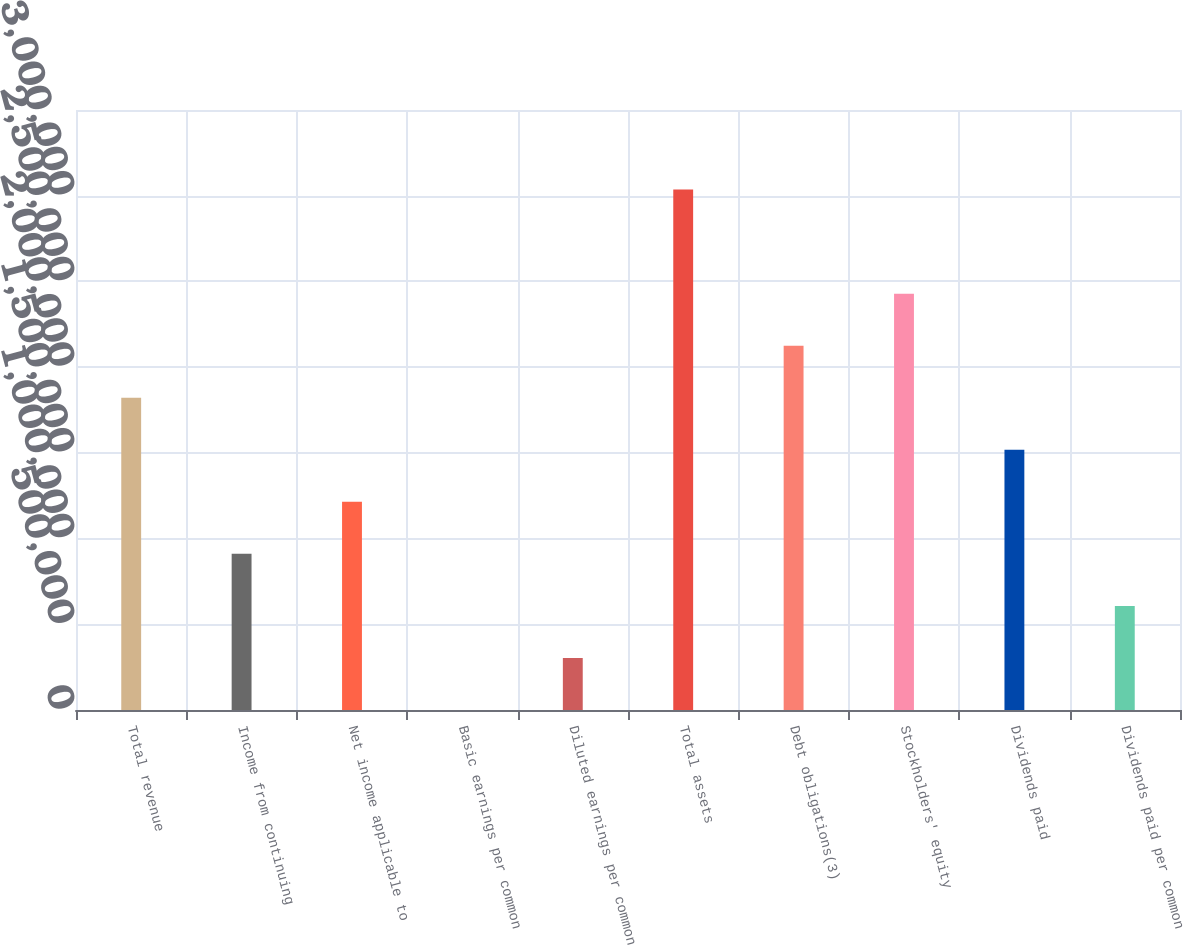Convert chart to OTSL. <chart><loc_0><loc_0><loc_500><loc_500><bar_chart><fcel>Total revenue<fcel>Income from continuing<fcel>Net income applicable to<fcel>Basic earnings per common<fcel>Diluted earnings per common<fcel>Total assets<fcel>Debt obligations(3)<fcel>Stockholders' equity<fcel>Dividends paid<fcel>Dividends paid per common<nl><fcel>1.82157e+06<fcel>910787<fcel>1.21438e+06<fcel>0.39<fcel>303596<fcel>3.03596e+06<fcel>2.12517e+06<fcel>2.42877e+06<fcel>1.51798e+06<fcel>607192<nl></chart> 